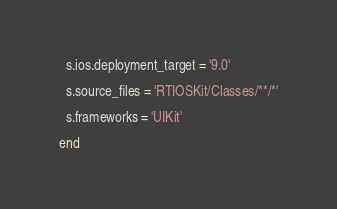<code> <loc_0><loc_0><loc_500><loc_500><_Ruby_>  s.ios.deployment_target = '9.0'

  s.source_files = 'RTIOSKit/Classes/**/*'
  
  s.frameworks = 'UIKit'
  
end
</code> 